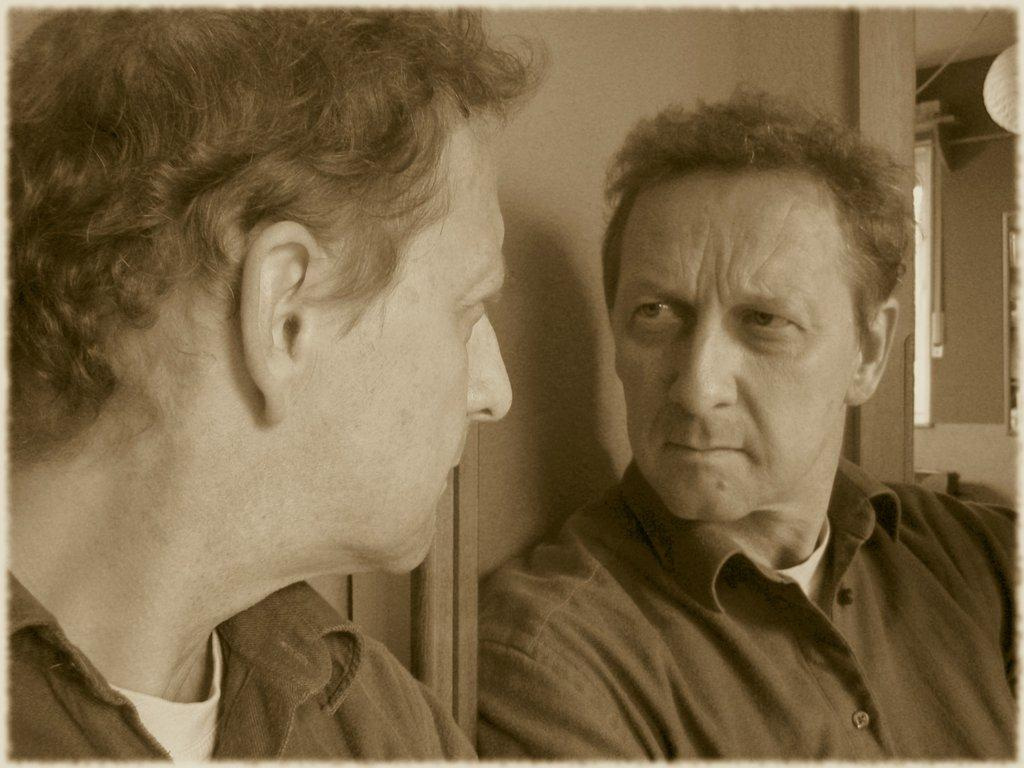What is the main subject in the image? There is a man standing in the image. What object is present in the image besides the man? There is a glass in the image. Can you describe any additional details about the man in the image? The man's reflection is visible in the glass is visible in the image. How many toads can be seen jumping in the image? There are no toads present in the image, and therefore no jumping toads can be observed. 